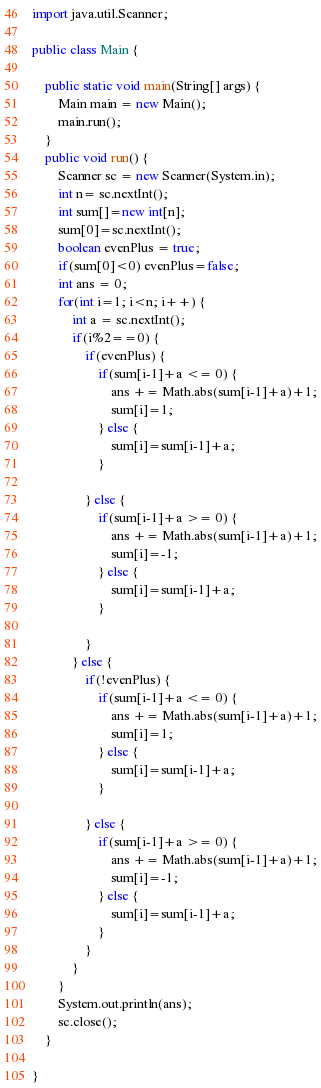Convert code to text. <code><loc_0><loc_0><loc_500><loc_500><_Java_>
import java.util.Scanner;

public class Main {

	public static void main(String[] args) {
		Main main = new Main();
		main.run();
	}
	public void run() {
		Scanner sc = new Scanner(System.in);
		int n= sc.nextInt();
		int sum[]=new int[n];
		sum[0]=sc.nextInt();
		boolean evenPlus = true;
		if(sum[0]<0) evenPlus=false;
		int ans = 0;
		for(int i=1; i<n; i++) {
			int a = sc.nextInt();
			if(i%2==0) {
				if(evenPlus) {
					if(sum[i-1]+a <= 0) {
						ans += Math.abs(sum[i-1]+a)+1;
						sum[i]=1;
					} else {
						sum[i]=sum[i-1]+a;
					}

				} else {
					if(sum[i-1]+a >= 0) {
						ans += Math.abs(sum[i-1]+a)+1;
						sum[i]=-1;
					} else {
						sum[i]=sum[i-1]+a;
					}

				}
			} else {
				if(!evenPlus) {
					if(sum[i-1]+a <= 0) {
						ans += Math.abs(sum[i-1]+a)+1;
						sum[i]=1;
					} else {
						sum[i]=sum[i-1]+a;
					}

				} else {
					if(sum[i-1]+a >= 0) {
						ans += Math.abs(sum[i-1]+a)+1;
						sum[i]=-1;
					} else {
						sum[i]=sum[i-1]+a;
					}
				}
			}
		}
		System.out.println(ans);
		sc.close();
	}

}</code> 